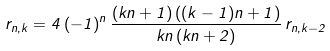Convert formula to latex. <formula><loc_0><loc_0><loc_500><loc_500>r _ { n , k } = 4 \, ( - 1 ) ^ { n } \, \frac { ( k n + 1 ) \, ( ( k - 1 ) n + 1 ) } { k n \, ( k n + 2 ) } \, r _ { n , k - 2 }</formula> 